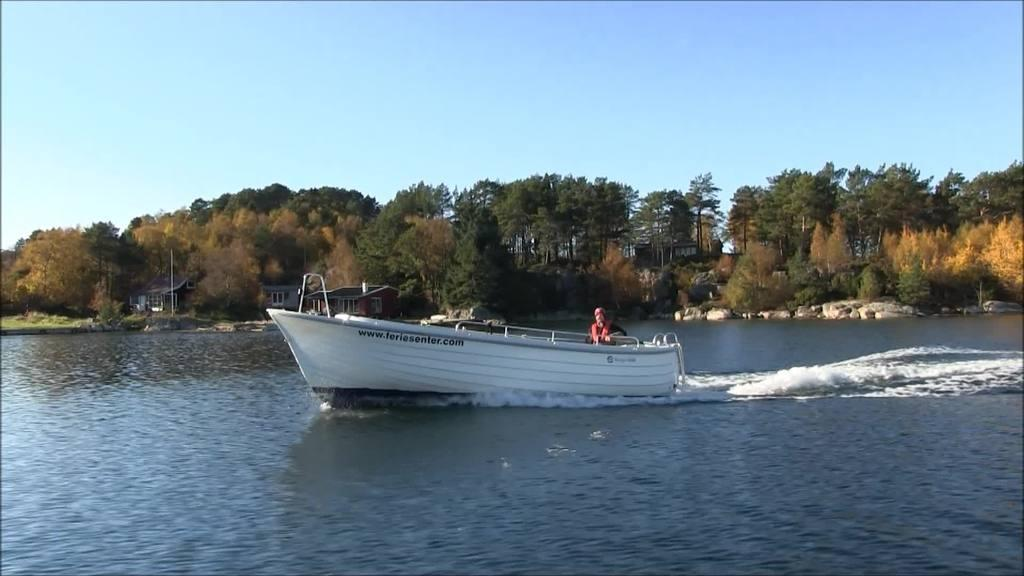What is the person in the image doing? There is a person riding a boat in the image. Where is the boat located? The boat is in the water. What other natural elements can be seen in the image? There are rocks and trees visible in the image. What type of structures are present in the image? There are houses in the image. What type of glove is the person wearing while riding the boat in the image? There is no glove visible in the image; the person is not wearing any gloves. 